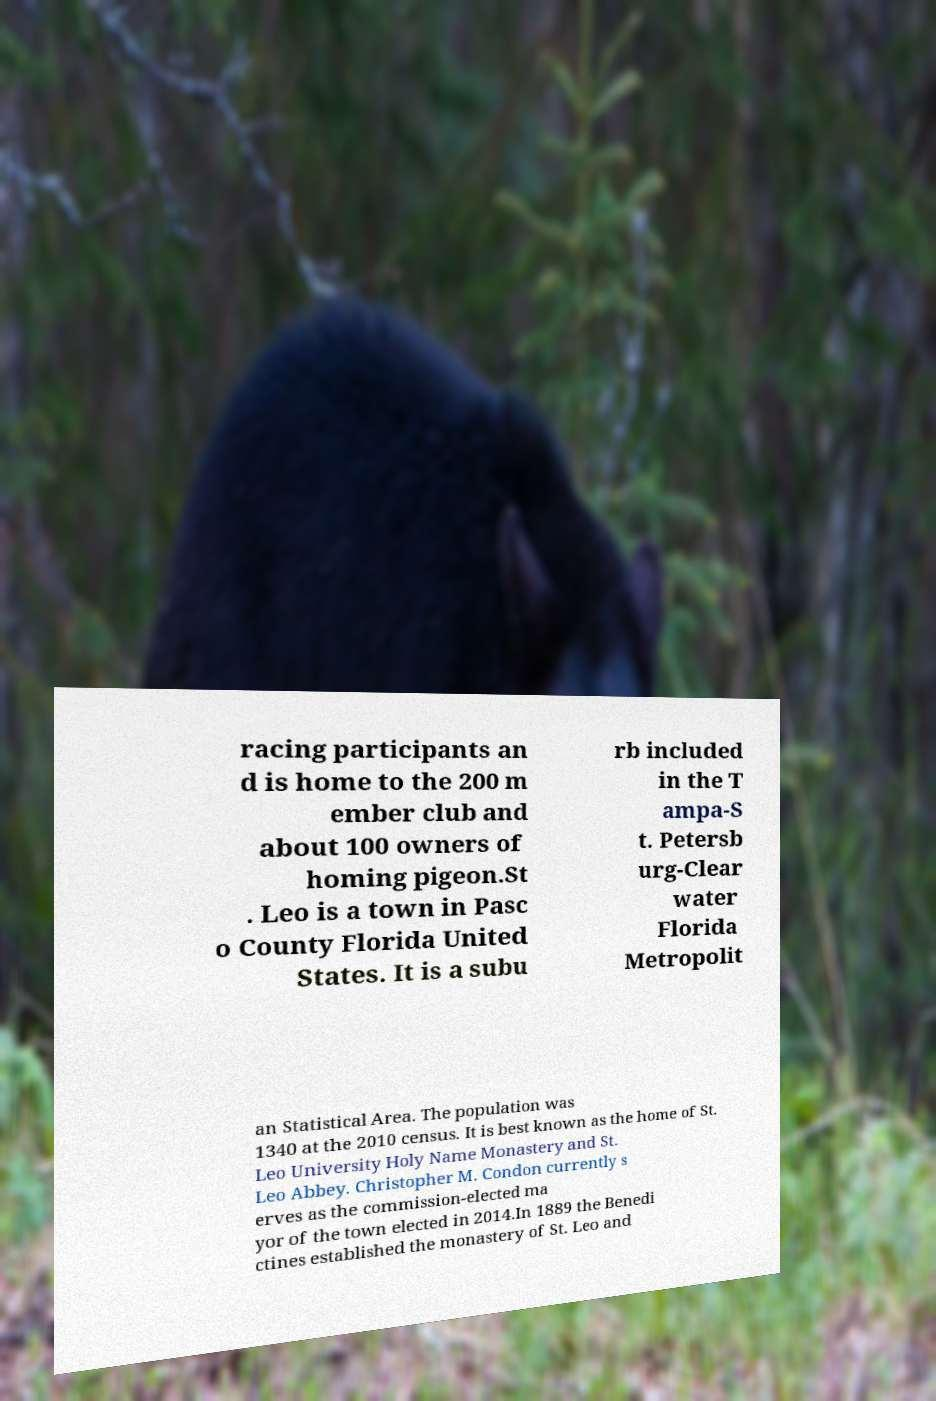Please read and relay the text visible in this image. What does it say? racing participants an d is home to the 200 m ember club and about 100 owners of homing pigeon.St . Leo is a town in Pasc o County Florida United States. It is a subu rb included in the T ampa-S t. Petersb urg-Clear water Florida Metropolit an Statistical Area. The population was 1340 at the 2010 census. It is best known as the home of St. Leo University Holy Name Monastery and St. Leo Abbey. Christopher M. Condon currently s erves as the commission-elected ma yor of the town elected in 2014.In 1889 the Benedi ctines established the monastery of St. Leo and 